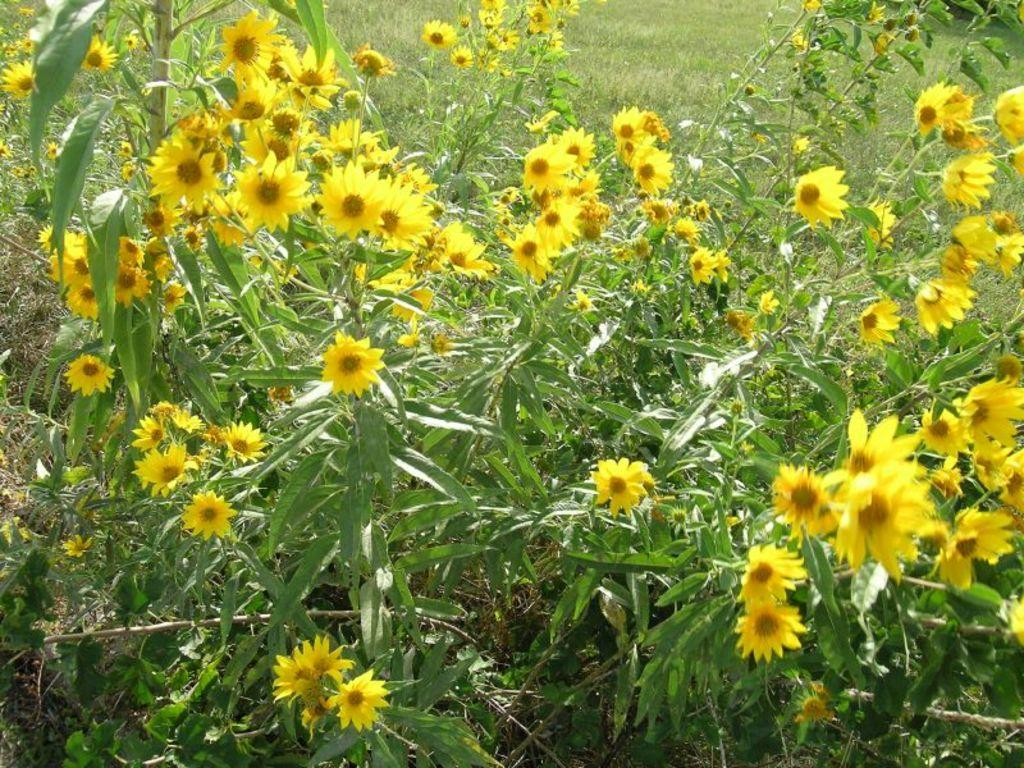What type of living organisms can be seen in the image? Plants can be seen in the image. What specific feature of the plants is visible? The plants have flowers. What color are the flowers? The flowers are yellow in color. What can be seen in the background of the image? There is grass visible in the background of the image. What type of box is being used to hold the balloon in the image? There is no box or balloon present in the image; it features plants with yellow flowers and grass in the background. 